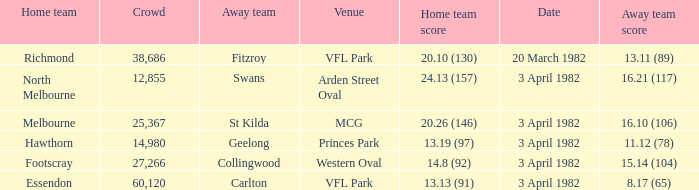Which home team played the away team of collingwood? Footscray. 